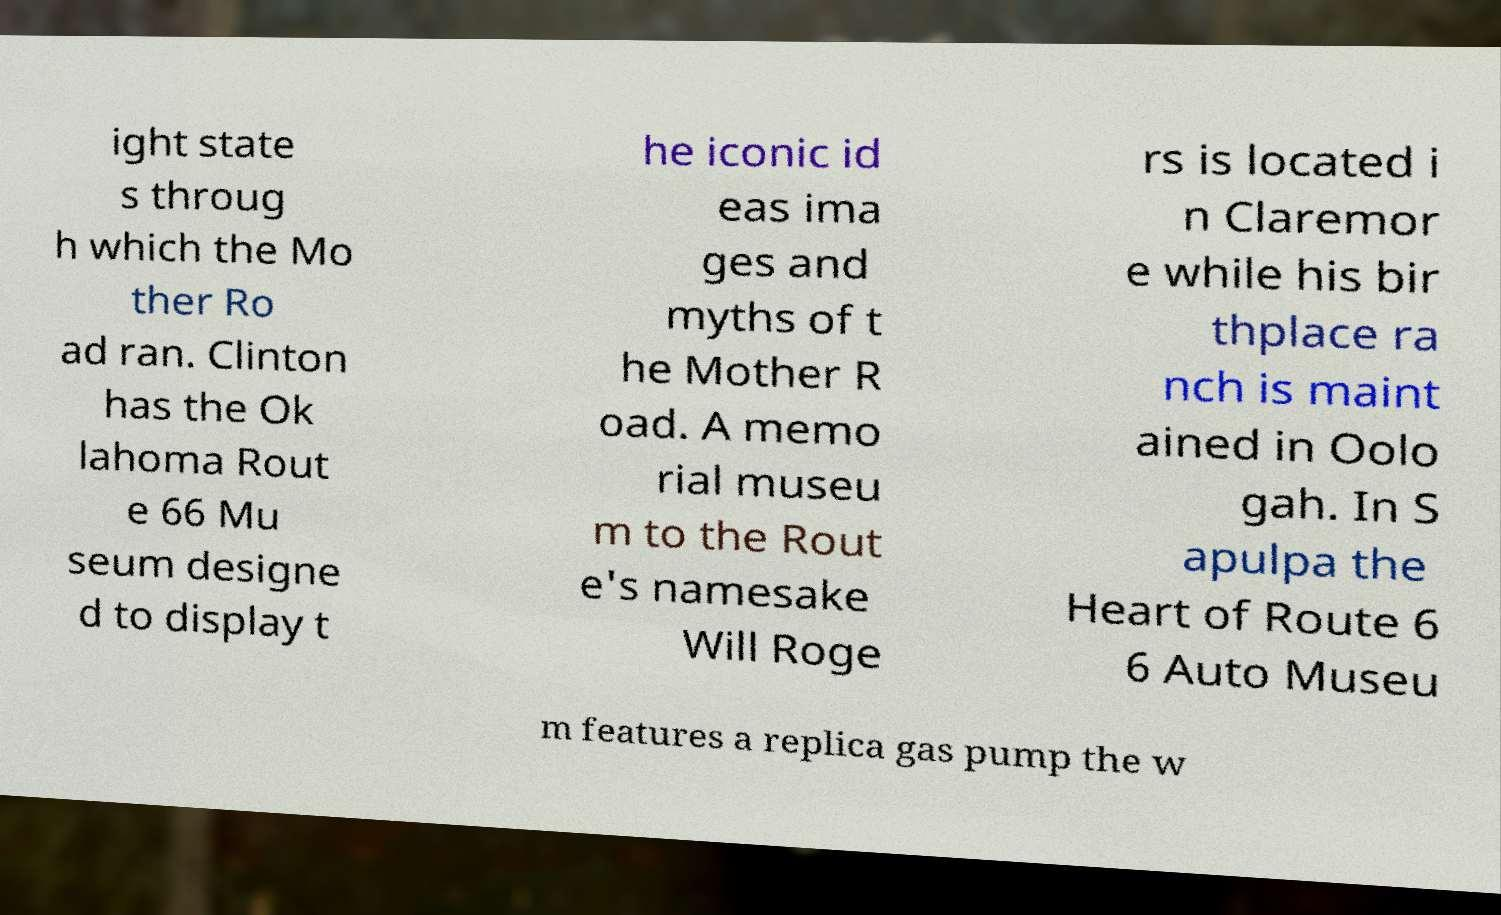What messages or text are displayed in this image? I need them in a readable, typed format. ight state s throug h which the Mo ther Ro ad ran. Clinton has the Ok lahoma Rout e 66 Mu seum designe d to display t he iconic id eas ima ges and myths of t he Mother R oad. A memo rial museu m to the Rout e's namesake Will Roge rs is located i n Claremor e while his bir thplace ra nch is maint ained in Oolo gah. In S apulpa the Heart of Route 6 6 Auto Museu m features a replica gas pump the w 